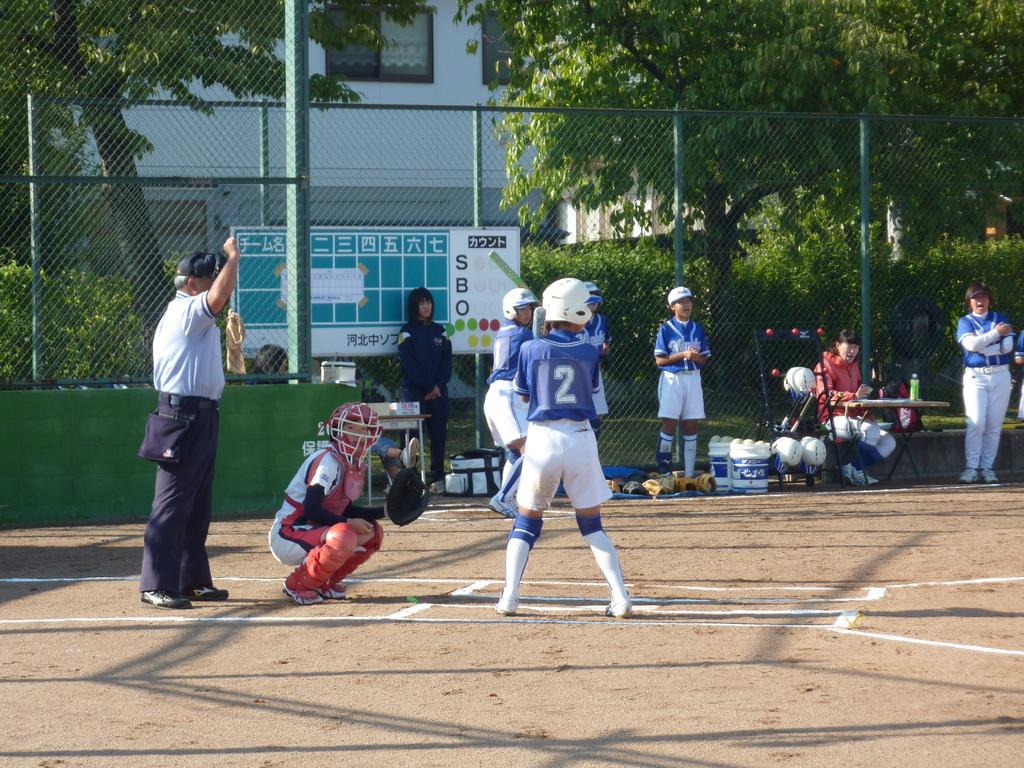What is the number of the player in the blue shirt?
Provide a succinct answer. 2. 